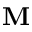Convert formula to latex. <formula><loc_0><loc_0><loc_500><loc_500>M</formula> 